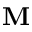Convert formula to latex. <formula><loc_0><loc_0><loc_500><loc_500>M</formula> 